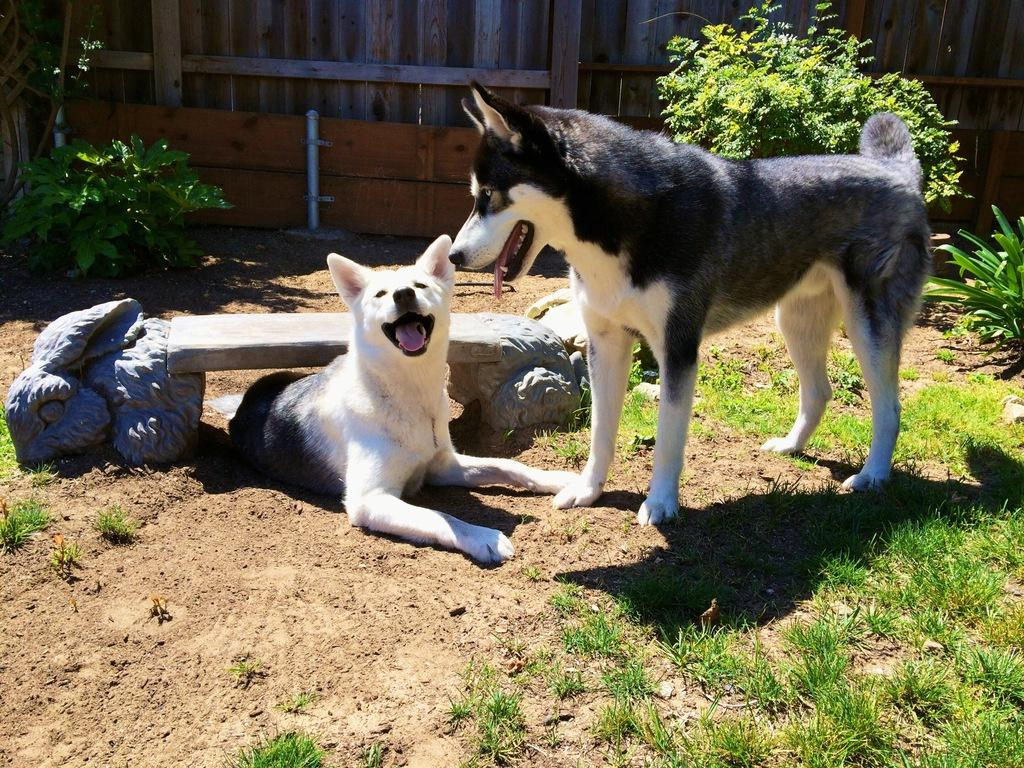What is located in the foreground of the picture? There is a bench, dogs, soil, grass, and a plant in the foreground of the picture. What type of animals can be seen in the foreground of the picture? Dogs can be seen in the foreground of the picture. What type of terrain is visible in the foreground of the picture? Soil and grass are visible in the foreground of the picture. What is growing in the foreground of the picture? There is a plant in the foreground of the picture. What can be seen in the background of the picture? There are trees and a wooden railing in the background of the picture. What country is the picture taken in? The provided facts do not mention the country where the picture was taken, so it cannot be determined from the image. What time of day is it in the picture? The provided facts do not mention the time of day when the picture was taken, so it cannot be determined from the image. 